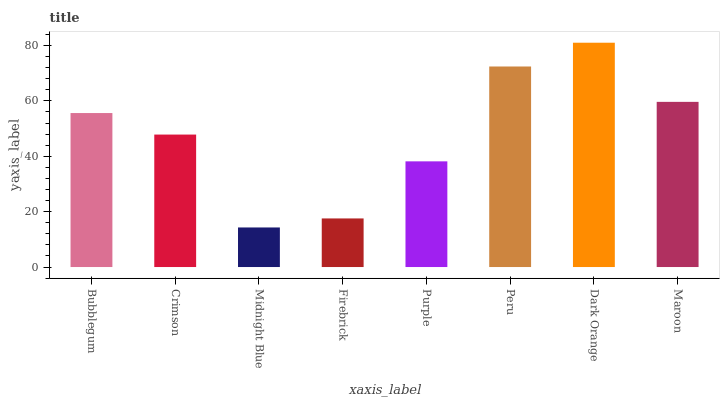Is Midnight Blue the minimum?
Answer yes or no. Yes. Is Dark Orange the maximum?
Answer yes or no. Yes. Is Crimson the minimum?
Answer yes or no. No. Is Crimson the maximum?
Answer yes or no. No. Is Bubblegum greater than Crimson?
Answer yes or no. Yes. Is Crimson less than Bubblegum?
Answer yes or no. Yes. Is Crimson greater than Bubblegum?
Answer yes or no. No. Is Bubblegum less than Crimson?
Answer yes or no. No. Is Bubblegum the high median?
Answer yes or no. Yes. Is Crimson the low median?
Answer yes or no. Yes. Is Crimson the high median?
Answer yes or no. No. Is Dark Orange the low median?
Answer yes or no. No. 